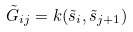Convert formula to latex. <formula><loc_0><loc_0><loc_500><loc_500>\tilde { G } _ { i j } = k ( \tilde { s } _ { i } , \tilde { s } _ { j + 1 } )</formula> 